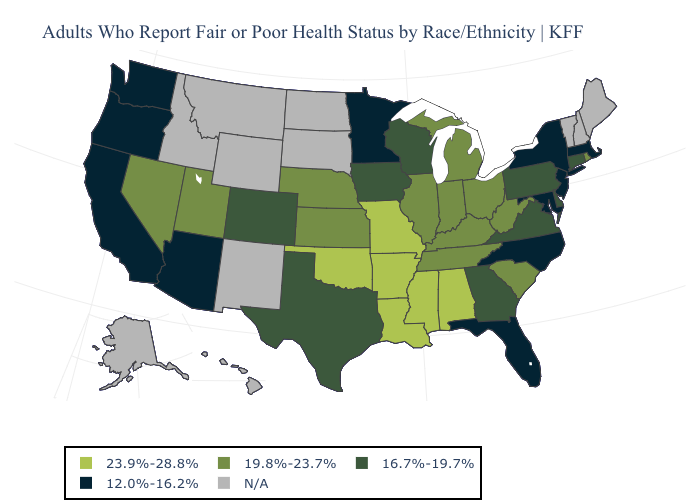Name the states that have a value in the range N/A?
Short answer required. Alaska, Hawaii, Idaho, Maine, Montana, New Hampshire, New Mexico, North Dakota, South Dakota, Vermont, Wyoming. What is the value of Texas?
Answer briefly. 16.7%-19.7%. Does Kansas have the highest value in the USA?
Write a very short answer. No. Does Minnesota have the lowest value in the USA?
Give a very brief answer. Yes. Does Missouri have the highest value in the MidWest?
Quick response, please. Yes. What is the value of Utah?
Concise answer only. 19.8%-23.7%. What is the value of Georgia?
Write a very short answer. 16.7%-19.7%. Which states have the lowest value in the USA?
Short answer required. Arizona, California, Florida, Maryland, Massachusetts, Minnesota, New Jersey, New York, North Carolina, Oregon, Washington. Among the states that border Ohio , does Pennsylvania have the highest value?
Be succinct. No. Among the states that border Kentucky , which have the lowest value?
Write a very short answer. Virginia. What is the value of North Carolina?
Quick response, please. 12.0%-16.2%. What is the value of South Carolina?
Give a very brief answer. 19.8%-23.7%. Name the states that have a value in the range 16.7%-19.7%?
Quick response, please. Colorado, Connecticut, Delaware, Georgia, Iowa, Pennsylvania, Texas, Virginia, Wisconsin. Does Utah have the lowest value in the USA?
Be succinct. No. Name the states that have a value in the range N/A?
Give a very brief answer. Alaska, Hawaii, Idaho, Maine, Montana, New Hampshire, New Mexico, North Dakota, South Dakota, Vermont, Wyoming. 